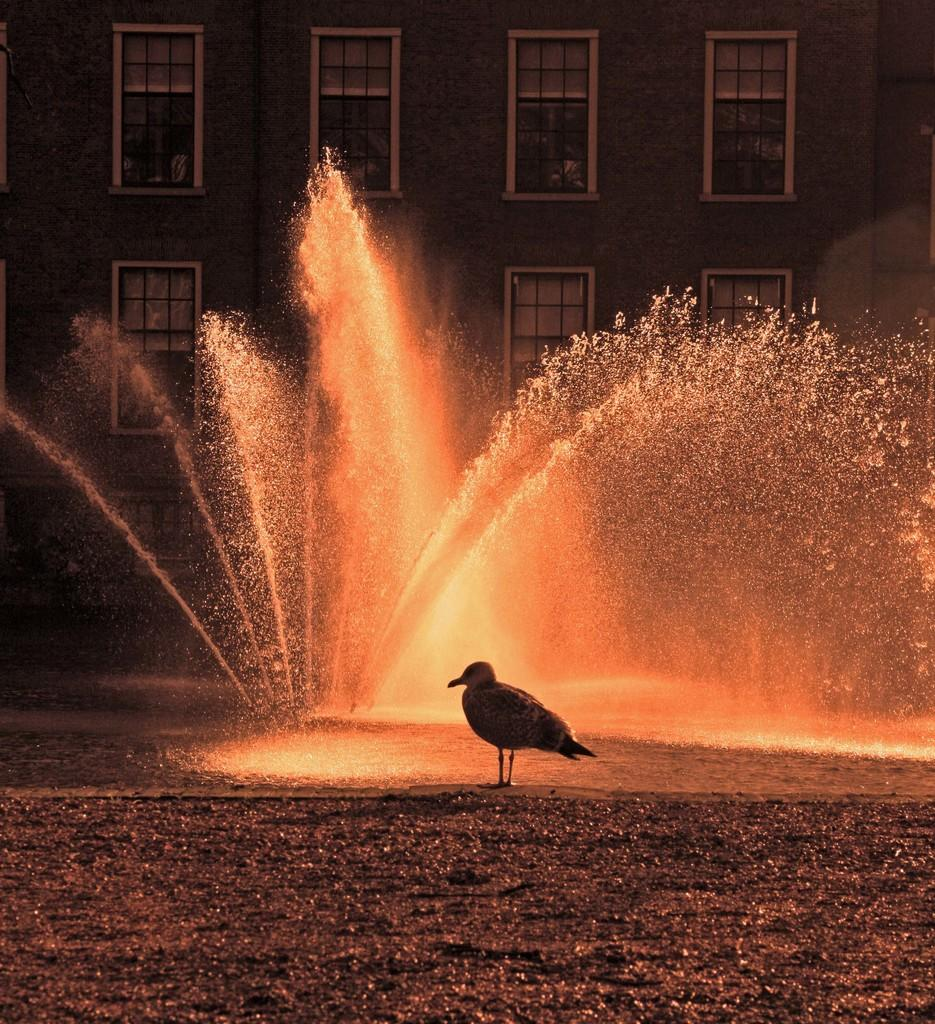What is located in the foreground of the image? There is a bird in the foreground of the image. What can be seen in the background of the image? There is a building and glass windows in the background of the image. What is the main event happening in the middle of the image? Fireworks are visible in the middle of the image. What type of ink is being used by the spiders in the image? There are no spiders present in the image, so there is no ink being used. Is there a battle taking place in the image? There is no battle depicted in the image; it features a bird, a building, glass windows, and fireworks. 